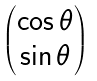<formula> <loc_0><loc_0><loc_500><loc_500>\begin{pmatrix} \cos \theta \\ \sin \theta \end{pmatrix}</formula> 